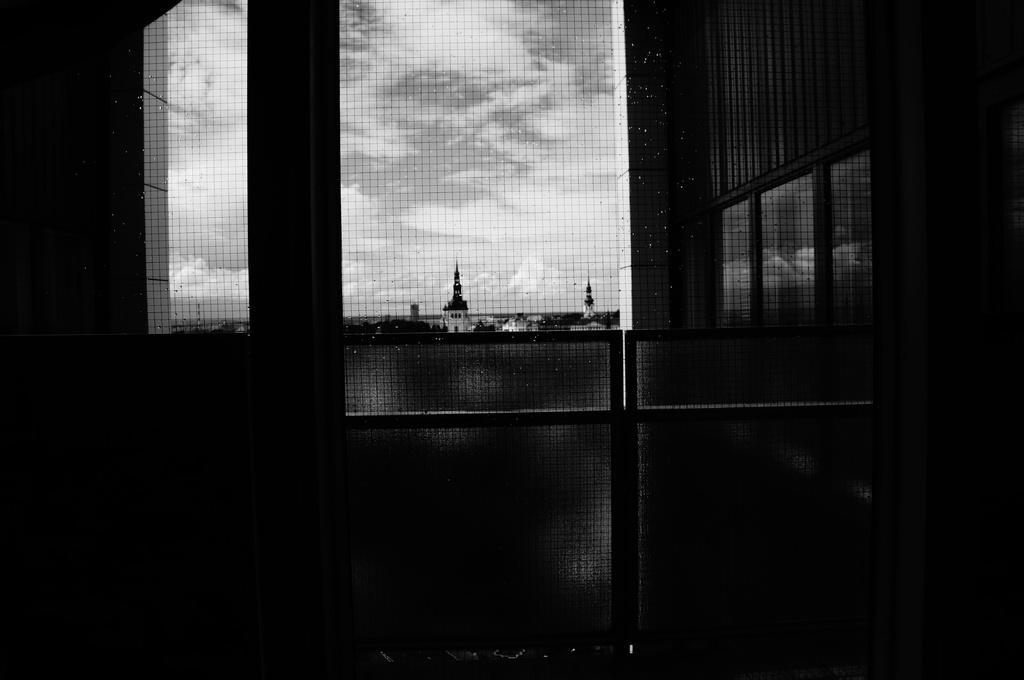Could you give a brief overview of what you see in this image? In this image in the front there is the gate and there is a fence, behind the fence there are towers. On the right side there are windows and the sky is cloudy. On the left side there is a wall. 